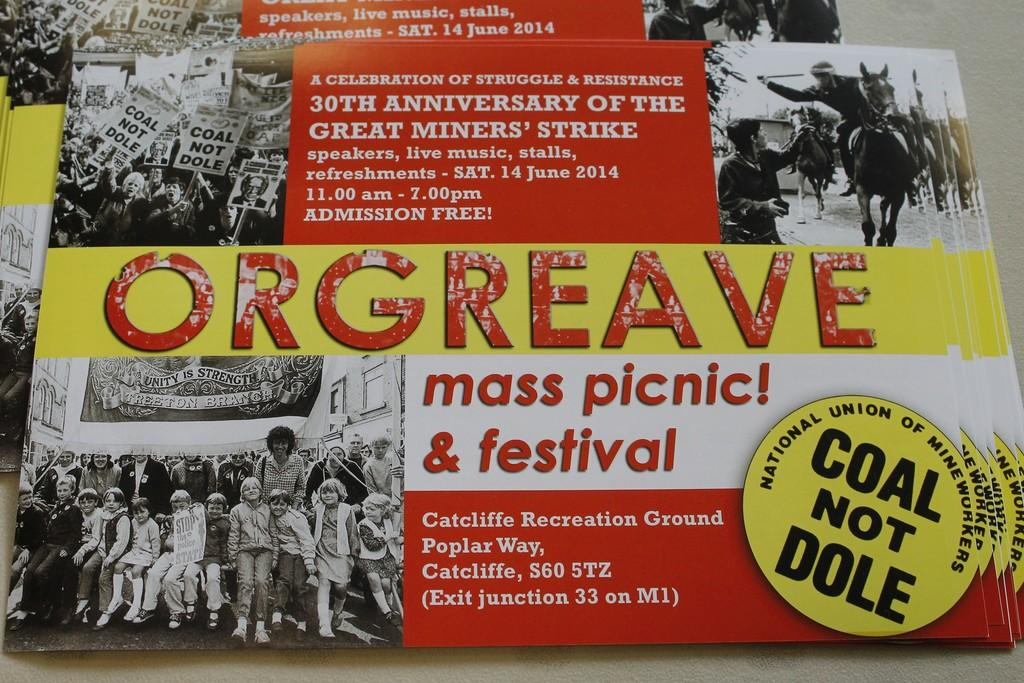<image>
Provide a brief description of the given image. Business card that says "Mass panic" and "Coal not Dole". 